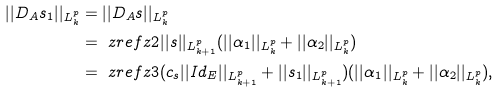Convert formula to latex. <formula><loc_0><loc_0><loc_500><loc_500>| | D _ { A } s _ { 1 } | | _ { L _ { k } ^ { p } } & = | | D _ { A } s | | _ { L _ { k } ^ { p } } \\ & = \ z r e f { z 2 } | | s | | _ { L _ { k + 1 } ^ { p } } ( | | \alpha _ { 1 } | | _ { L _ { k } ^ { p } } + | | \alpha _ { 2 } | | _ { L _ { k } ^ { p } } ) \\ & = \ z r e f { z 3 } ( c _ { s } | | I d _ { E } | | _ { L _ { k + 1 } ^ { p } } + | | s _ { 1 } | | _ { L _ { k + 1 } ^ { p } } ) ( | | \alpha _ { 1 } | | _ { L _ { k } ^ { p } } + | | \alpha _ { 2 } | | _ { L _ { k } ^ { p } } ) , \\</formula> 